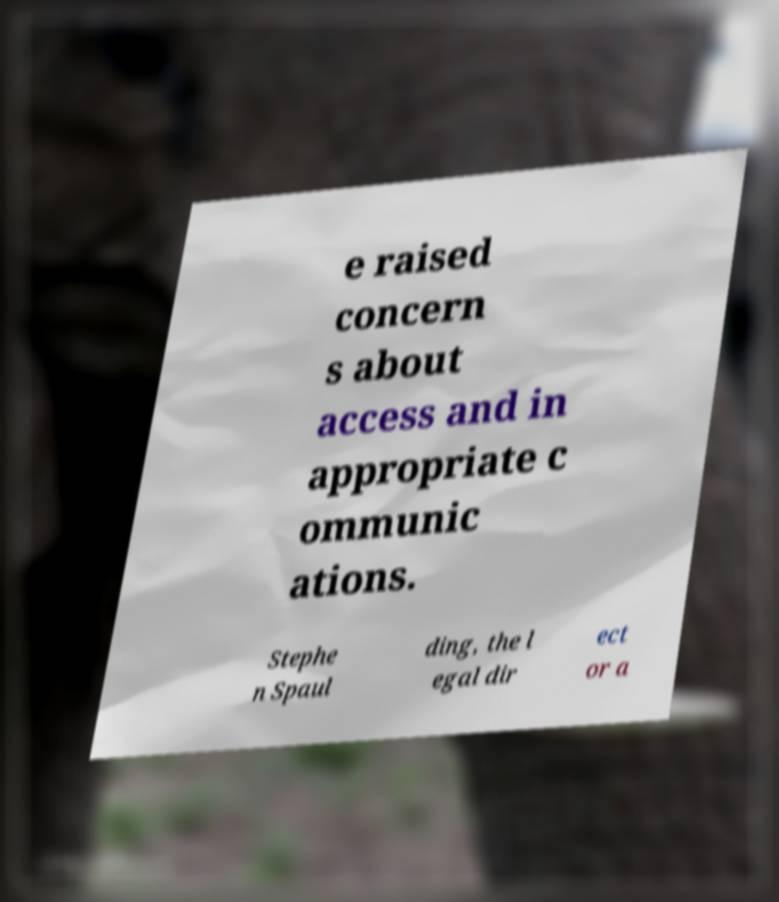Can you accurately transcribe the text from the provided image for me? e raised concern s about access and in appropriate c ommunic ations. Stephe n Spaul ding, the l egal dir ect or a 